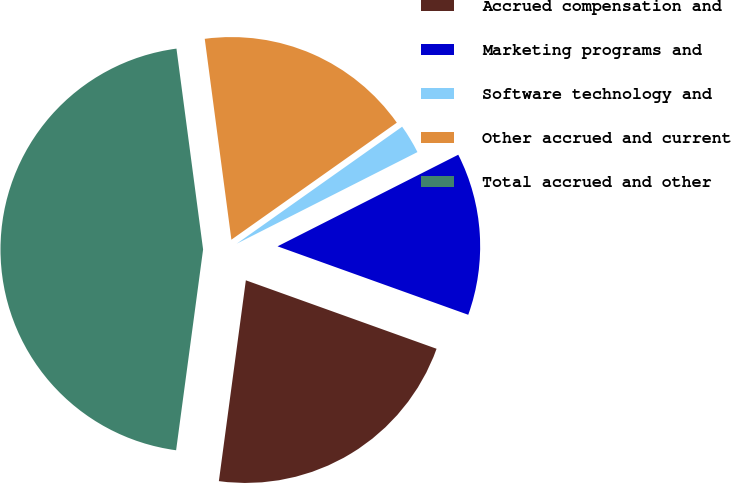Convert chart to OTSL. <chart><loc_0><loc_0><loc_500><loc_500><pie_chart><fcel>Accrued compensation and<fcel>Marketing programs and<fcel>Software technology and<fcel>Other accrued and current<fcel>Total accrued and other<nl><fcel>21.64%<fcel>12.95%<fcel>2.33%<fcel>17.3%<fcel>45.77%<nl></chart> 